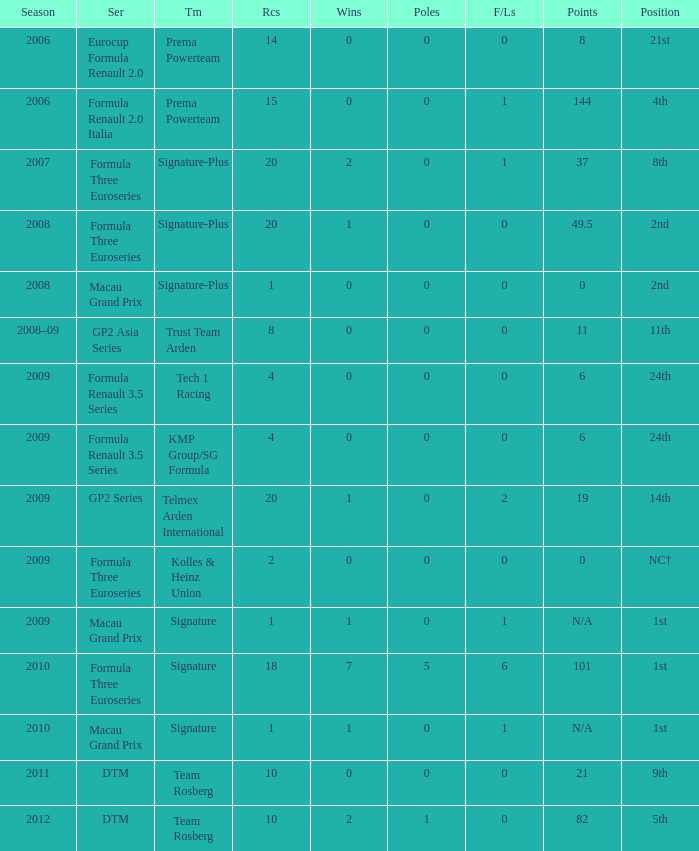How many poles are there in the Formula Three Euroseries in the 2008 season with more than 0 F/Laps? None. 